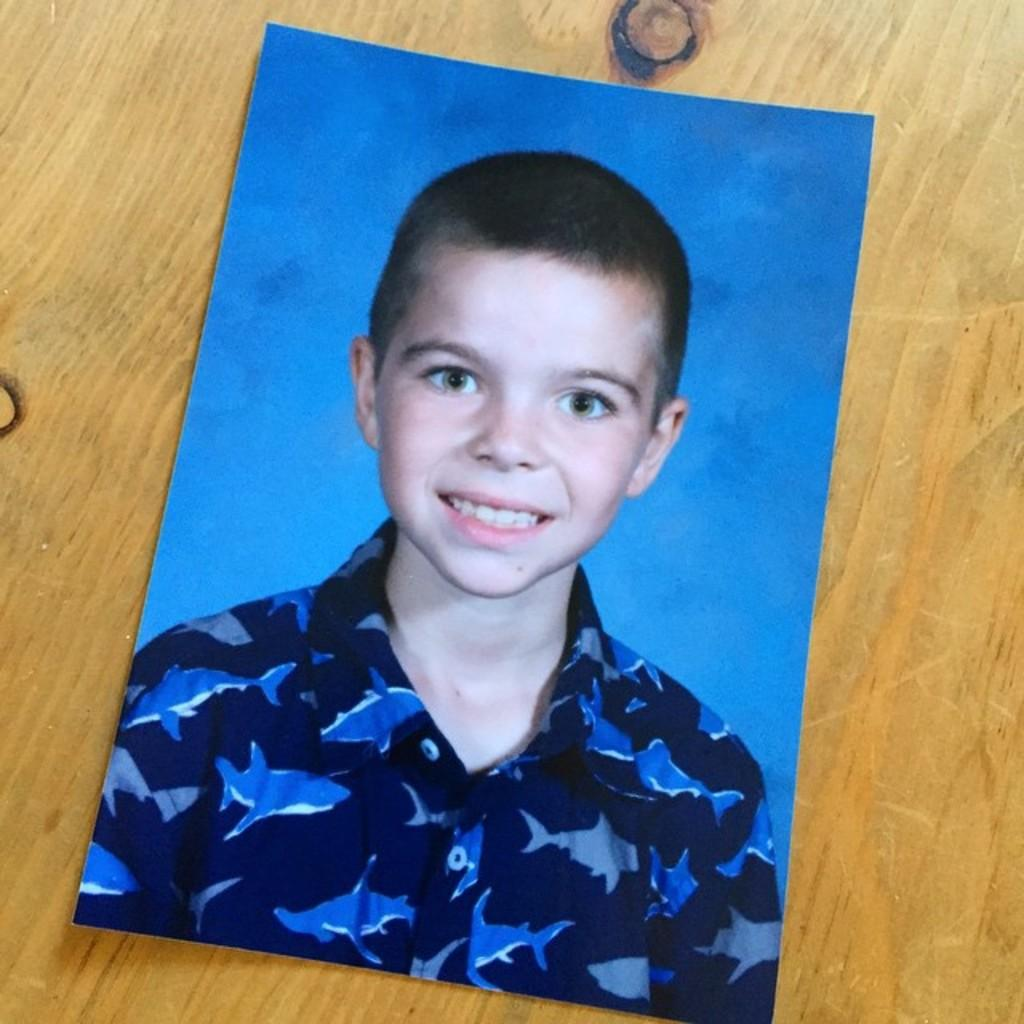What is the main subject of the image? There is a photo of a person in the image. Where is the photo placed? The photo is placed on a wooden surface. Can you see a snail crawling on the wooden surface in the image? No, there is no snail present in the image. 